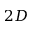<formula> <loc_0><loc_0><loc_500><loc_500>2 D</formula> 